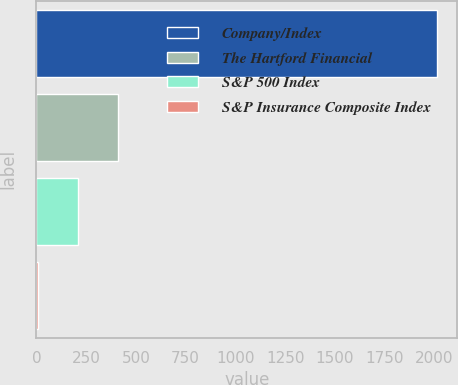<chart> <loc_0><loc_0><loc_500><loc_500><bar_chart><fcel>Company/Index<fcel>The Hartford Financial<fcel>S&P 500 Index<fcel>S&P Insurance Composite Index<nl><fcel>2014<fcel>409.43<fcel>208.86<fcel>8.29<nl></chart> 